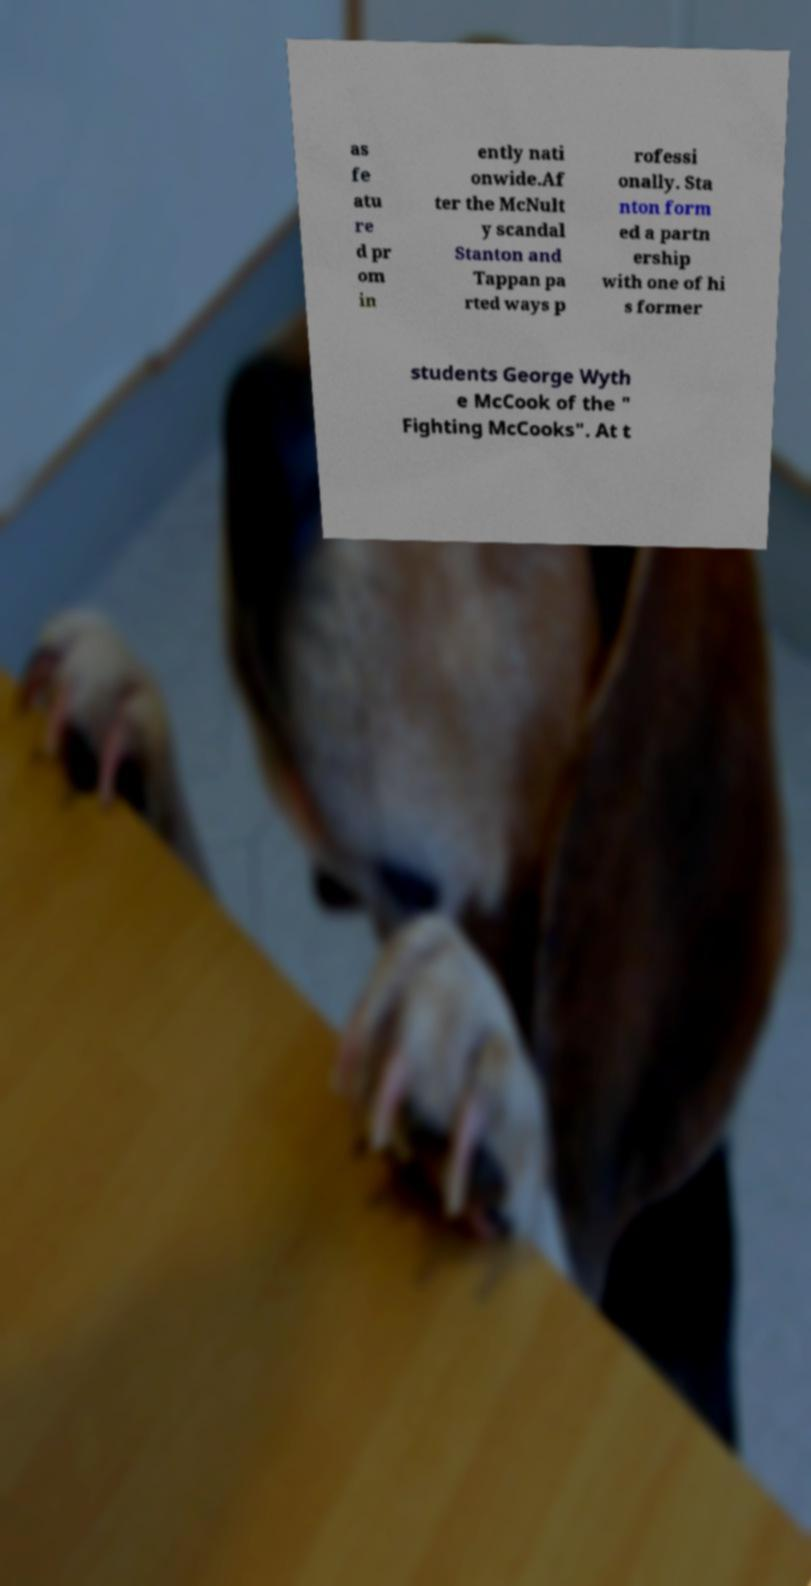What messages or text are displayed in this image? I need them in a readable, typed format. as fe atu re d pr om in ently nati onwide.Af ter the McNult y scandal Stanton and Tappan pa rted ways p rofessi onally. Sta nton form ed a partn ership with one of hi s former students George Wyth e McCook of the " Fighting McCooks". At t 